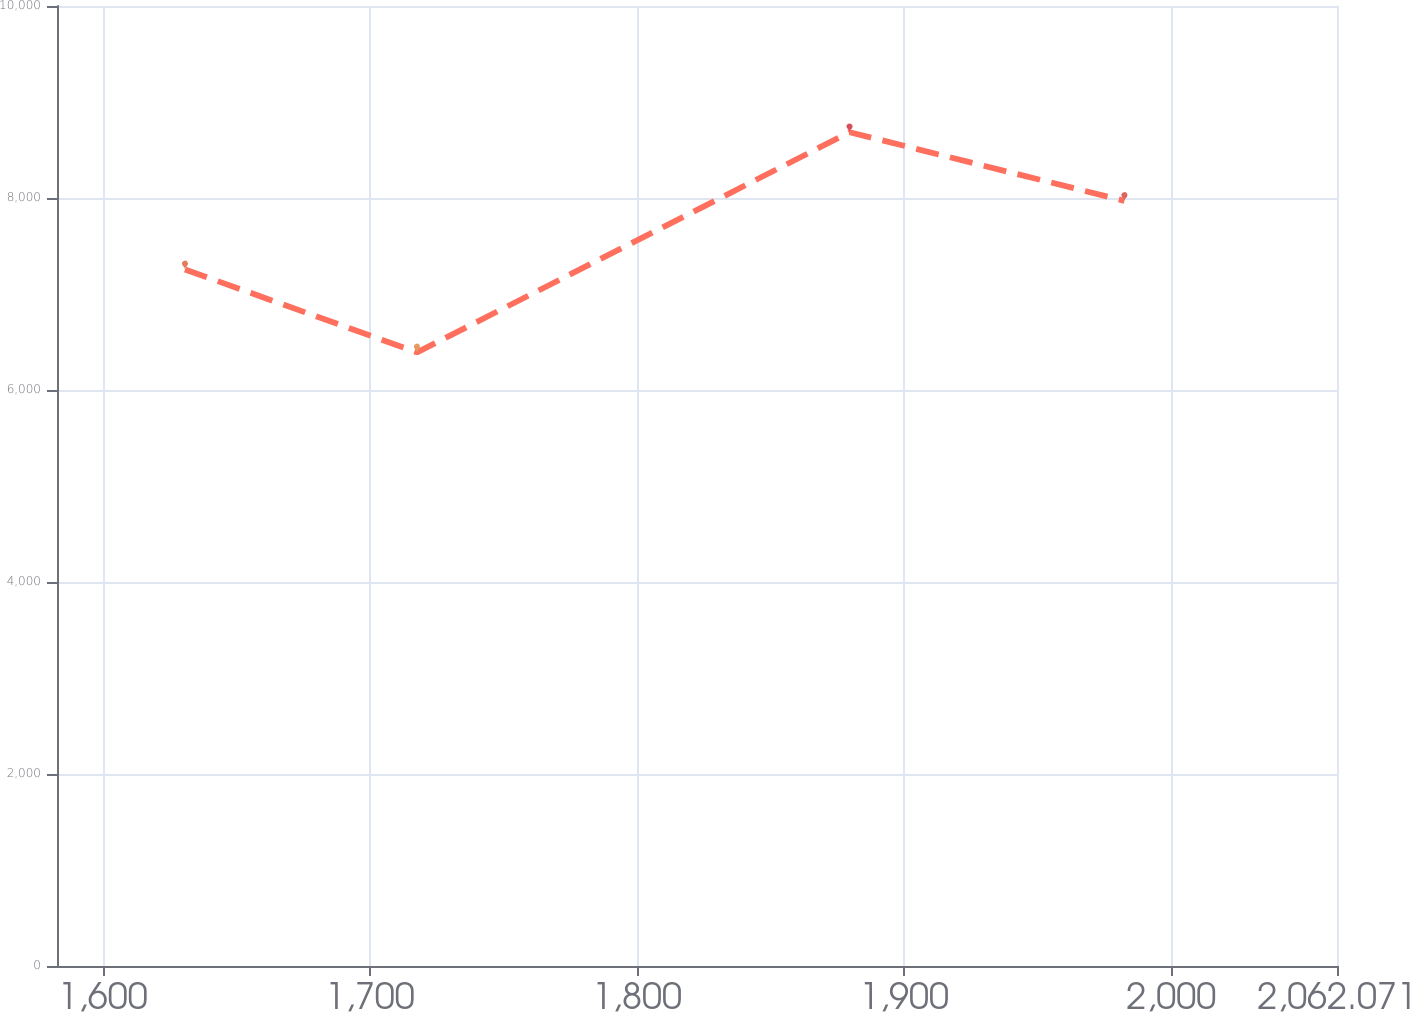Convert chart. <chart><loc_0><loc_0><loc_500><loc_500><line_chart><ecel><fcel>Unnamed: 1<nl><fcel>1630.8<fcel>7256.22<nl><fcel>1717.65<fcel>6392.09<nl><fcel>1879.6<fcel>8685.07<nl><fcel>1982.5<fcel>7970.65<nl><fcel>2109.99<fcel>1418.43<nl></chart> 